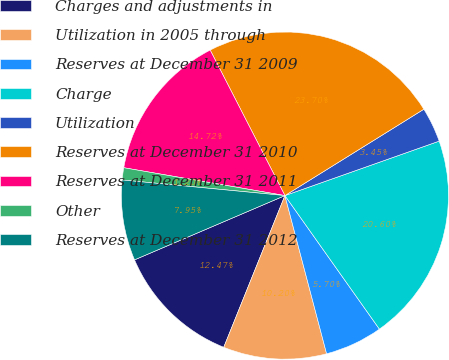<chart> <loc_0><loc_0><loc_500><loc_500><pie_chart><fcel>Charges and adjustments in<fcel>Utilization in 2005 through<fcel>Reserves at December 31 2009<fcel>Charge<fcel>Utilization<fcel>Reserves at December 31 2010<fcel>Reserves at December 31 2011<fcel>Other<fcel>Reserves at December 31 2012<nl><fcel>12.47%<fcel>10.2%<fcel>5.7%<fcel>20.6%<fcel>3.45%<fcel>23.7%<fcel>14.72%<fcel>1.2%<fcel>7.95%<nl></chart> 